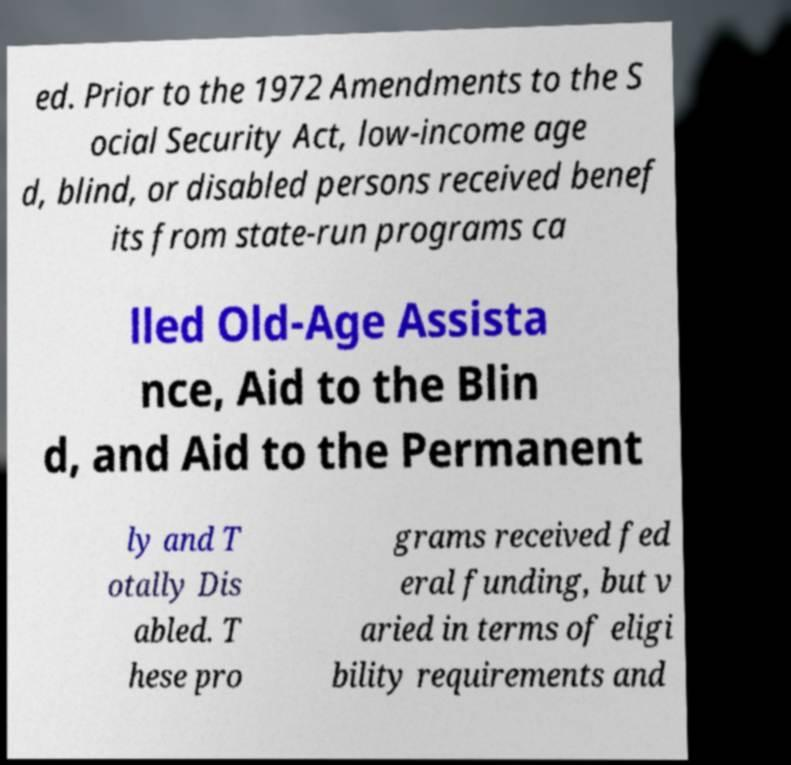Please read and relay the text visible in this image. What does it say? ed. Prior to the 1972 Amendments to the S ocial Security Act, low-income age d, blind, or disabled persons received benef its from state-run programs ca lled Old-Age Assista nce, Aid to the Blin d, and Aid to the Permanent ly and T otally Dis abled. T hese pro grams received fed eral funding, but v aried in terms of eligi bility requirements and 